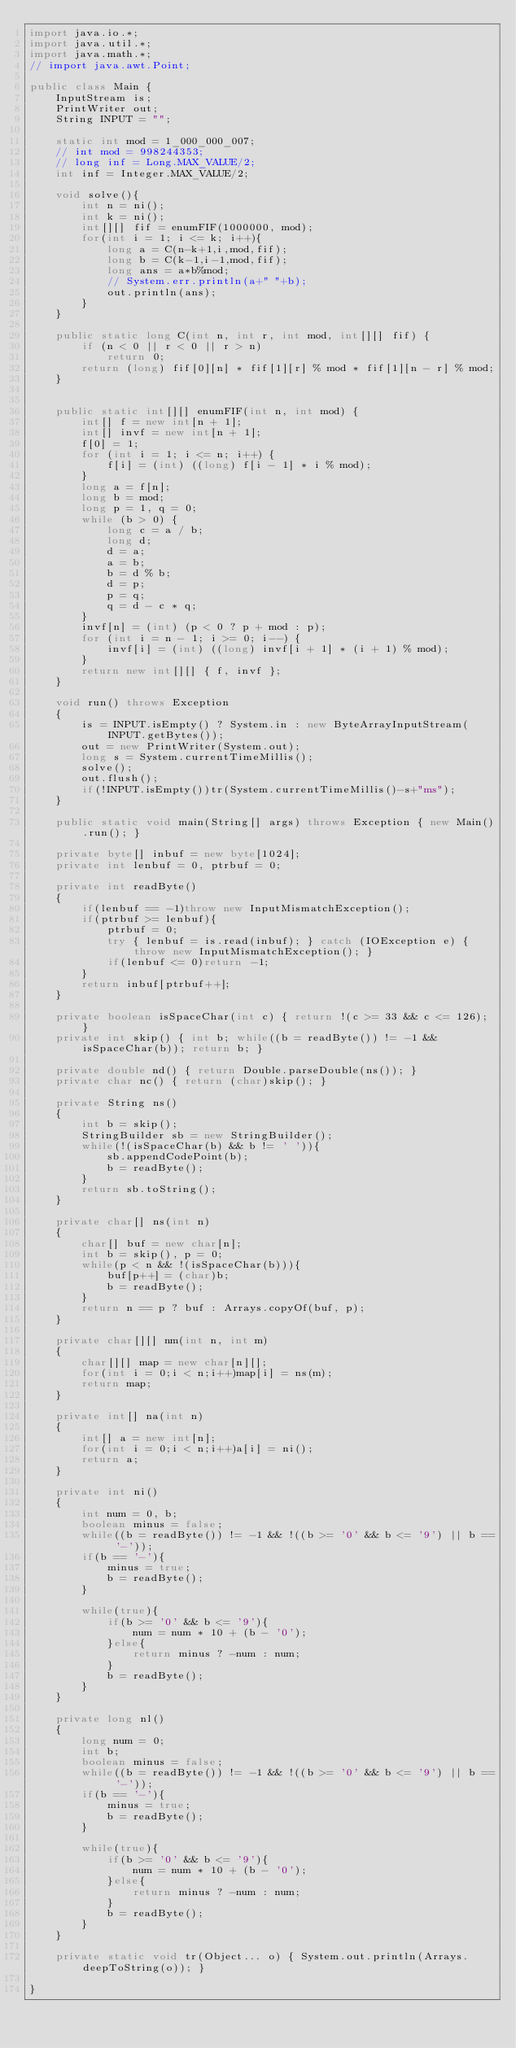Convert code to text. <code><loc_0><loc_0><loc_500><loc_500><_Java_>import java.io.*;
import java.util.*;
import java.math.*;
// import java.awt.Point;
 
public class Main {
    InputStream is;
    PrintWriter out;
    String INPUT = "";
 
    static int mod = 1_000_000_007;
    // int mod = 998244353;
    // long inf = Long.MAX_VALUE/2;
    int inf = Integer.MAX_VALUE/2;

    void solve(){
        int n = ni();
        int k = ni();
        int[][] fif = enumFIF(1000000, mod);
        for(int i = 1; i <= k; i++){
            long a = C(n-k+1,i,mod,fif);
            long b = C(k-1,i-1,mod,fif);
            long ans = a*b%mod;
            // System.err.println(a+" "+b);
            out.println(ans);
        }
    }

    public static long C(int n, int r, int mod, int[][] fif) {
        if (n < 0 || r < 0 || r > n)
            return 0;
        return (long) fif[0][n] * fif[1][r] % mod * fif[1][n - r] % mod;
    }

    
    public static int[][] enumFIF(int n, int mod) {
        int[] f = new int[n + 1];
        int[] invf = new int[n + 1];
        f[0] = 1;
        for (int i = 1; i <= n; i++) {
            f[i] = (int) ((long) f[i - 1] * i % mod);
        }
        long a = f[n];
        long b = mod;
        long p = 1, q = 0;
        while (b > 0) {
            long c = a / b;
            long d;
            d = a;
            a = b;
            b = d % b;
            d = p;
            p = q;
            q = d - c * q;
        }
        invf[n] = (int) (p < 0 ? p + mod : p);
        for (int i = n - 1; i >= 0; i--) {
            invf[i] = (int) ((long) invf[i + 1] * (i + 1) % mod);
        }
        return new int[][] { f, invf };
    }

    void run() throws Exception
    {
        is = INPUT.isEmpty() ? System.in : new ByteArrayInputStream(INPUT.getBytes());
        out = new PrintWriter(System.out);
        long s = System.currentTimeMillis();
        solve();
        out.flush();
        if(!INPUT.isEmpty())tr(System.currentTimeMillis()-s+"ms");
    }
    
    public static void main(String[] args) throws Exception { new Main().run(); }
    
    private byte[] inbuf = new byte[1024];
    private int lenbuf = 0, ptrbuf = 0;
    
    private int readByte()
    {
        if(lenbuf == -1)throw new InputMismatchException();
        if(ptrbuf >= lenbuf){
            ptrbuf = 0;
            try { lenbuf = is.read(inbuf); } catch (IOException e) { throw new InputMismatchException(); }
            if(lenbuf <= 0)return -1;
        }
        return inbuf[ptrbuf++];
    }
    
    private boolean isSpaceChar(int c) { return !(c >= 33 && c <= 126); }
    private int skip() { int b; while((b = readByte()) != -1 && isSpaceChar(b)); return b; }
    
    private double nd() { return Double.parseDouble(ns()); }
    private char nc() { return (char)skip(); }
    
    private String ns()
    {
        int b = skip();
        StringBuilder sb = new StringBuilder();
        while(!(isSpaceChar(b) && b != ' ')){
            sb.appendCodePoint(b);
            b = readByte();
        }
        return sb.toString();
    }
    
    private char[] ns(int n)
    {
        char[] buf = new char[n];
        int b = skip(), p = 0;
        while(p < n && !(isSpaceChar(b))){
            buf[p++] = (char)b;
            b = readByte();
        }
        return n == p ? buf : Arrays.copyOf(buf, p);
    }
    
    private char[][] nm(int n, int m)
    {
        char[][] map = new char[n][];
        for(int i = 0;i < n;i++)map[i] = ns(m);
        return map;
    }
    
    private int[] na(int n)
    {
        int[] a = new int[n];
        for(int i = 0;i < n;i++)a[i] = ni();
        return a;
    }
    
    private int ni()
    {
        int num = 0, b;
        boolean minus = false;
        while((b = readByte()) != -1 && !((b >= '0' && b <= '9') || b == '-'));
        if(b == '-'){
            minus = true;
            b = readByte();
        }
        
        while(true){
            if(b >= '0' && b <= '9'){
                num = num * 10 + (b - '0');
            }else{
                return minus ? -num : num;
            }
            b = readByte();
        }
    }
    
    private long nl()
    {
        long num = 0;
        int b;
        boolean minus = false;
        while((b = readByte()) != -1 && !((b >= '0' && b <= '9') || b == '-'));
        if(b == '-'){
            minus = true;
            b = readByte();
        }
        
        while(true){
            if(b >= '0' && b <= '9'){
                num = num * 10 + (b - '0');
            }else{
                return minus ? -num : num;
            }
            b = readByte();
        }
    }
    
    private static void tr(Object... o) { System.out.println(Arrays.deepToString(o)); }
 
}
</code> 